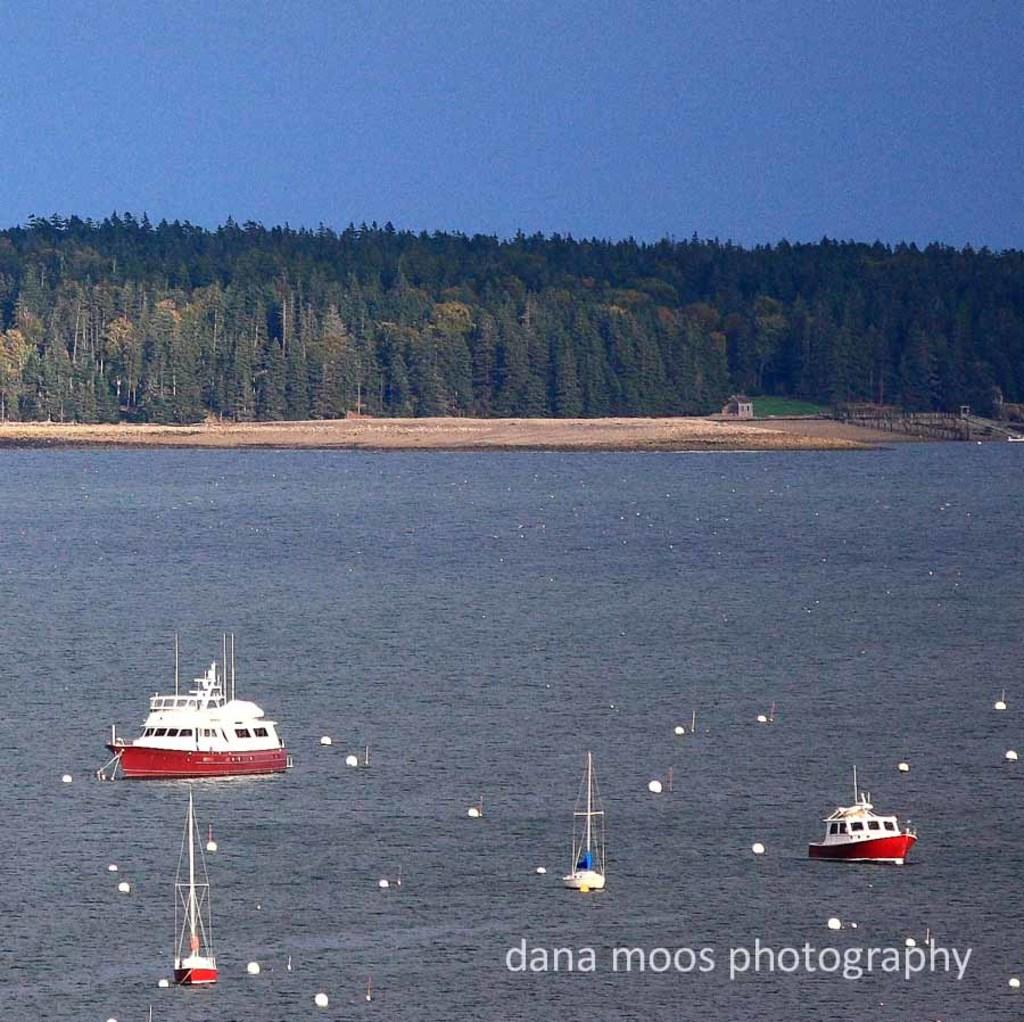<image>
Give a short and clear explanation of the subsequent image. Several boats in water in the foreground along with the text 'dana moos photography' and a tree-covered shoreline in the background. 